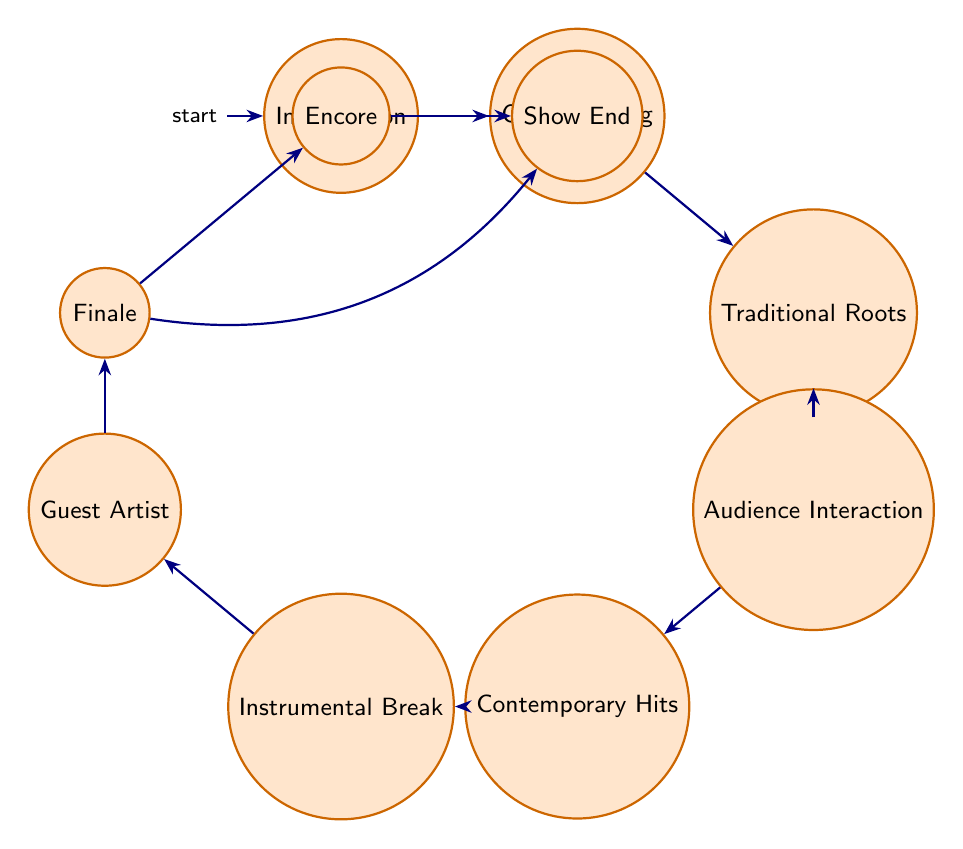What is the initial state of the performance setlist? The initial state, as indicated in the diagram, is represented with a special mark, showing it is the starting point. It is "Introduction".
Answer: Introduction How many nodes are there in the diagram? The diagram shows each state as a node, and counting these nodes gives a total of ten states.
Answer: 10 What is the transition from "Opening Song"? The "Opening Song" node has a direct transition to another node, which is "Traditional Roots Segment".
Answer: Traditional Roots Segment Which segment comes after "Audience Interaction"? Following the "Audience Interaction" state, the diagram shows a transition to the next state called "Contemporary Hits Segment".
Answer: Contemporary Hits Segment Where does the "Finale" state lead? The "Finale" state has two possible outgoing transitions. One leads directly to "Encore" while the other goes to "Show End", which indicates a potential ending without an encore.
Answer: Encore, Show End How does the "Instrumental Break" connect to other states? From "Instrumental Break", there is a clear transition to "Guest Artist Performance", indicating a sequential part of the performance following the instrumental showcase.
Answer: Guest Artist Performance What is the last state before the performance concludes? The last state that leads to the conclusion of the performance is "Encore" before finally moving to "Show End".
Answer: Encore Which state incorporates audience participation? The state specifically focused on audience engagement, where interactive elements occur, is "Audience Interaction".
Answer: Audience Interaction What is represented by the segment "Traditional Roots"? The "Traditional Roots Segment" emphasizes the integration of classic Afrobeat rhythms and traditional elements in the performance repertoire.
Answer: Incorporating traditional elements Which state highlights the skills of the musicians? The "Instrumental Break" is designated for showcasing the musicians' skills through instrumental solos, reflecting their talent.
Answer: Instrumental Break 